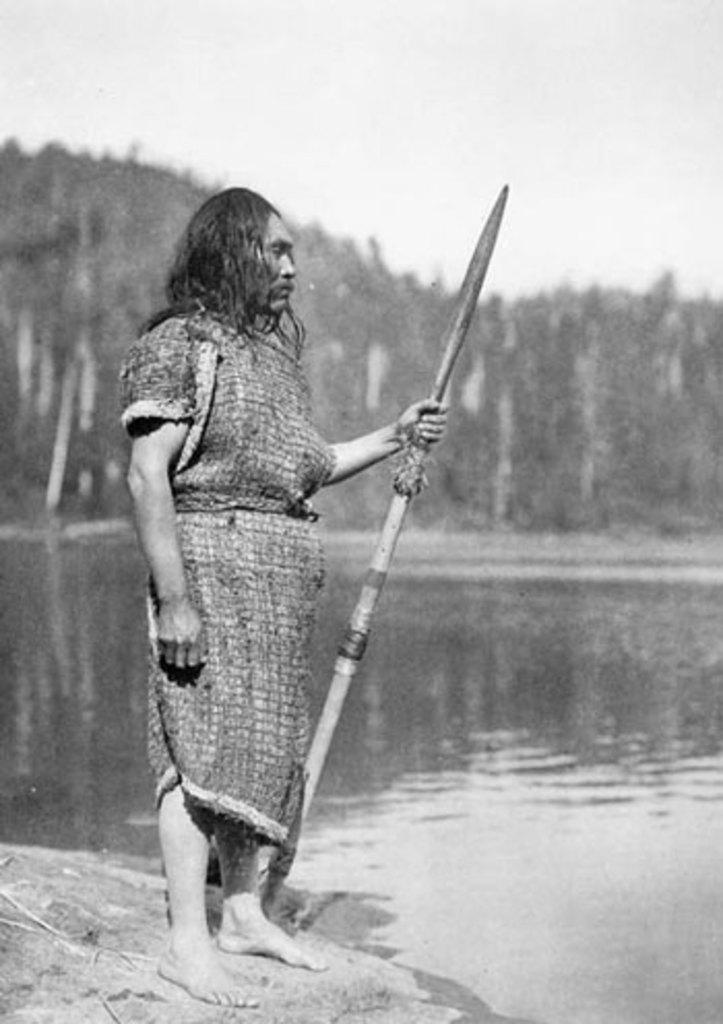What is the color scheme of the image? The image is black and white. What can be seen in the image? There is a person standing in the image. What is the person holding? The person is holding a stick. What is visible in the background of the image? There are trees in the background of the image. What is visible at the bottom of the image? There is water visible at the bottom of the image. Can you tell me how many times the person jumps in the image? There is no indication of the person jumping in the image; they are simply standing. What type of iron object is present in the image? There is no iron object present in the image. 